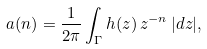Convert formula to latex. <formula><loc_0><loc_0><loc_500><loc_500>a ( n ) = \frac { 1 } { 2 \pi } \int _ { \Gamma } h ( z ) \, z ^ { - n } \, | d z | ,</formula> 